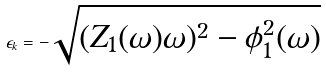Convert formula to latex. <formula><loc_0><loc_0><loc_500><loc_500>\epsilon _ { k } = - \sqrt { ( Z _ { 1 } ( \omega ) \omega ) ^ { 2 } - \phi ^ { 2 } _ { 1 } ( \omega ) }</formula> 